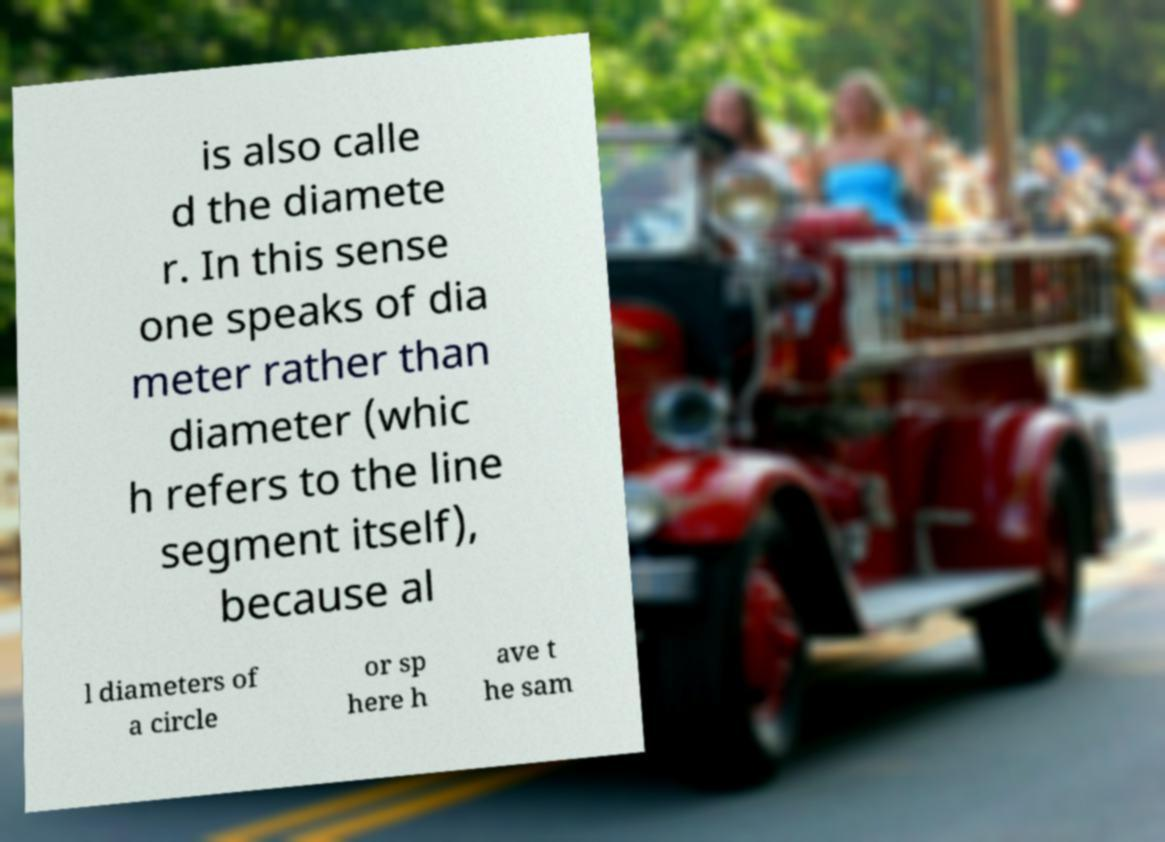Please identify and transcribe the text found in this image. is also calle d the diamete r. In this sense one speaks of dia meter rather than diameter (whic h refers to the line segment itself), because al l diameters of a circle or sp here h ave t he sam 